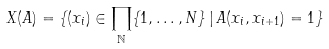Convert formula to latex. <formula><loc_0><loc_0><loc_500><loc_500>X ( A ) = \{ ( x _ { i } ) \in \prod _ { \mathbb { N } } \{ 1 , \dots , N \} \, | \, A ( x _ { i } , x _ { i + 1 } ) = 1 \}</formula> 